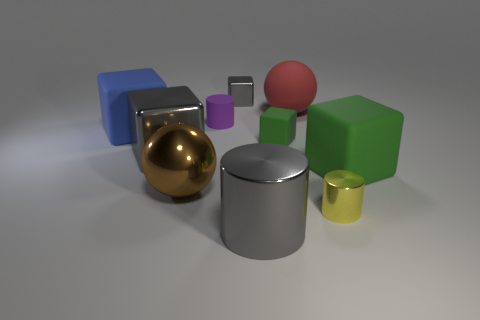How many shiny blocks are the same color as the large cylinder?
Your response must be concise. 2. How many objects are big matte cubes on the left side of the large gray shiny cylinder or big brown spheres?
Your answer should be very brief. 2. Is there anything else that has the same material as the tiny yellow object?
Your response must be concise. Yes. What number of cubes are behind the blue thing and on the left side of the tiny gray thing?
Keep it short and to the point. 0. What number of objects are either metal blocks behind the blue cube or rubber objects in front of the big matte ball?
Give a very brief answer. 5. What number of other things are there of the same shape as the small gray object?
Keep it short and to the point. 4. There is a big matte cube that is on the left side of the large green thing; is it the same color as the rubber sphere?
Offer a very short reply. No. How many other things are the same size as the brown thing?
Ensure brevity in your answer.  5. Do the purple thing and the small gray block have the same material?
Provide a short and direct response. No. There is a tiny metal thing that is in front of the tiny thing behind the small purple object; what is its color?
Offer a terse response. Yellow. 